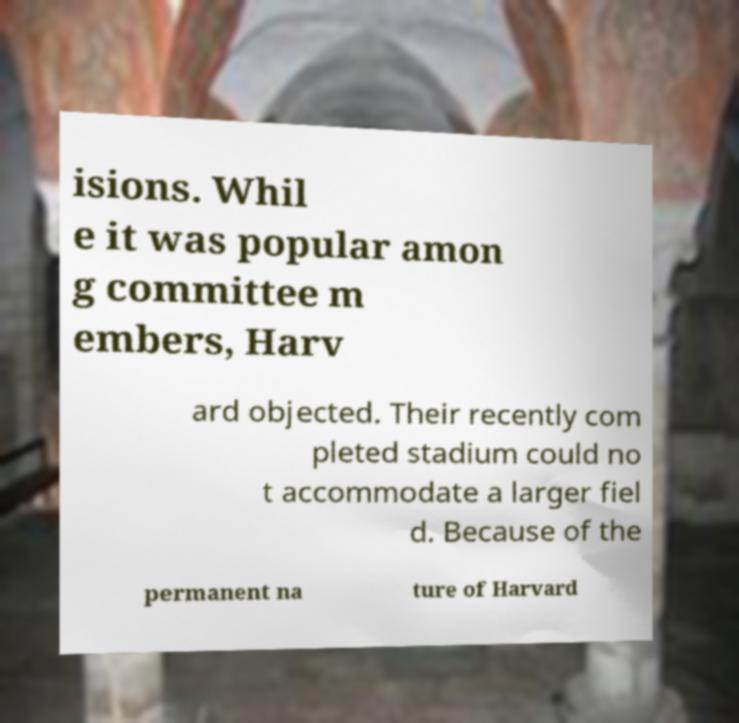For documentation purposes, I need the text within this image transcribed. Could you provide that? isions. Whil e it was popular amon g committee m embers, Harv ard objected. Their recently com pleted stadium could no t accommodate a larger fiel d. Because of the permanent na ture of Harvard 